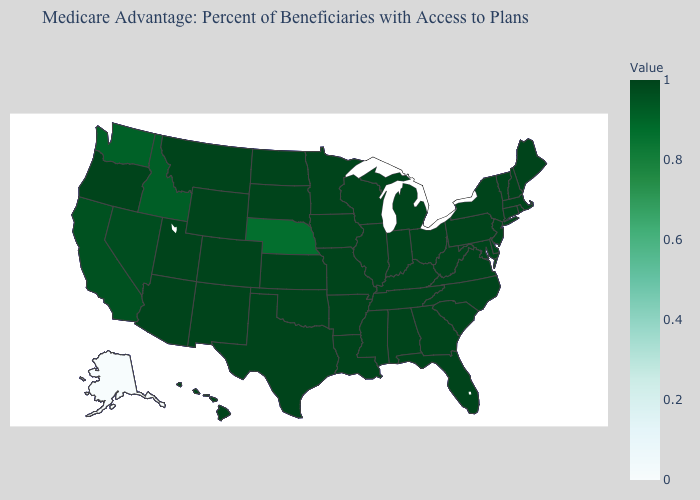Which states have the lowest value in the USA?
Keep it brief. Alaska. Which states have the lowest value in the USA?
Write a very short answer. Alaska. Among the states that border Wisconsin , does Iowa have the lowest value?
Be succinct. Yes. 